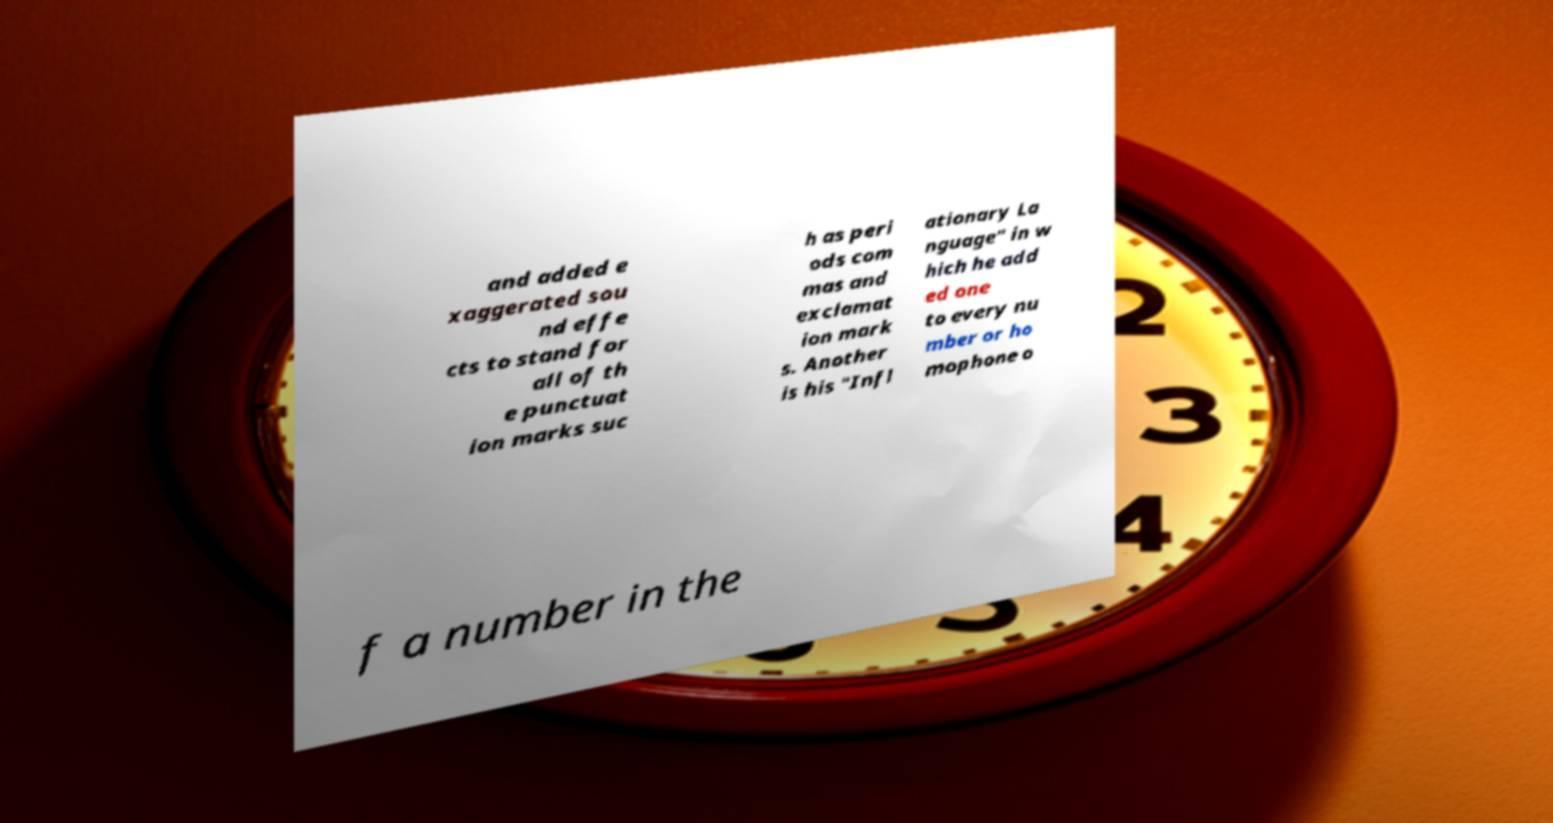Please read and relay the text visible in this image. What does it say? and added e xaggerated sou nd effe cts to stand for all of th e punctuat ion marks suc h as peri ods com mas and exclamat ion mark s. Another is his "Infl ationary La nguage" in w hich he add ed one to every nu mber or ho mophone o f a number in the 